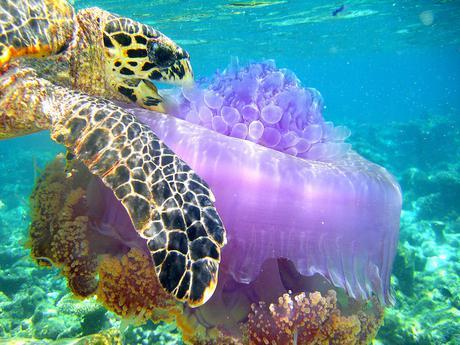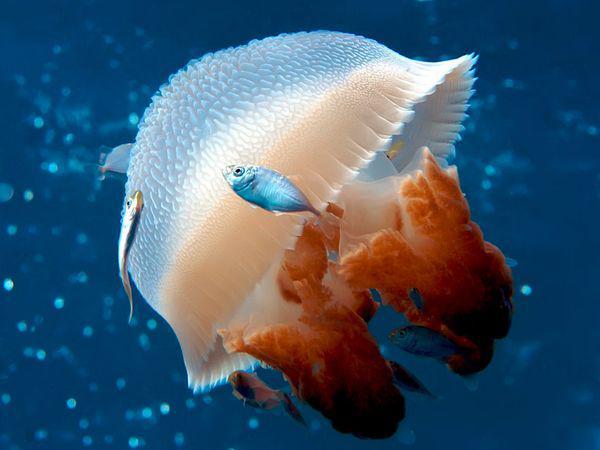The first image is the image on the left, the second image is the image on the right. Considering the images on both sides, is "Left image shows one animal to the left of a violet-tinted jellyfish." valid? Answer yes or no. Yes. 